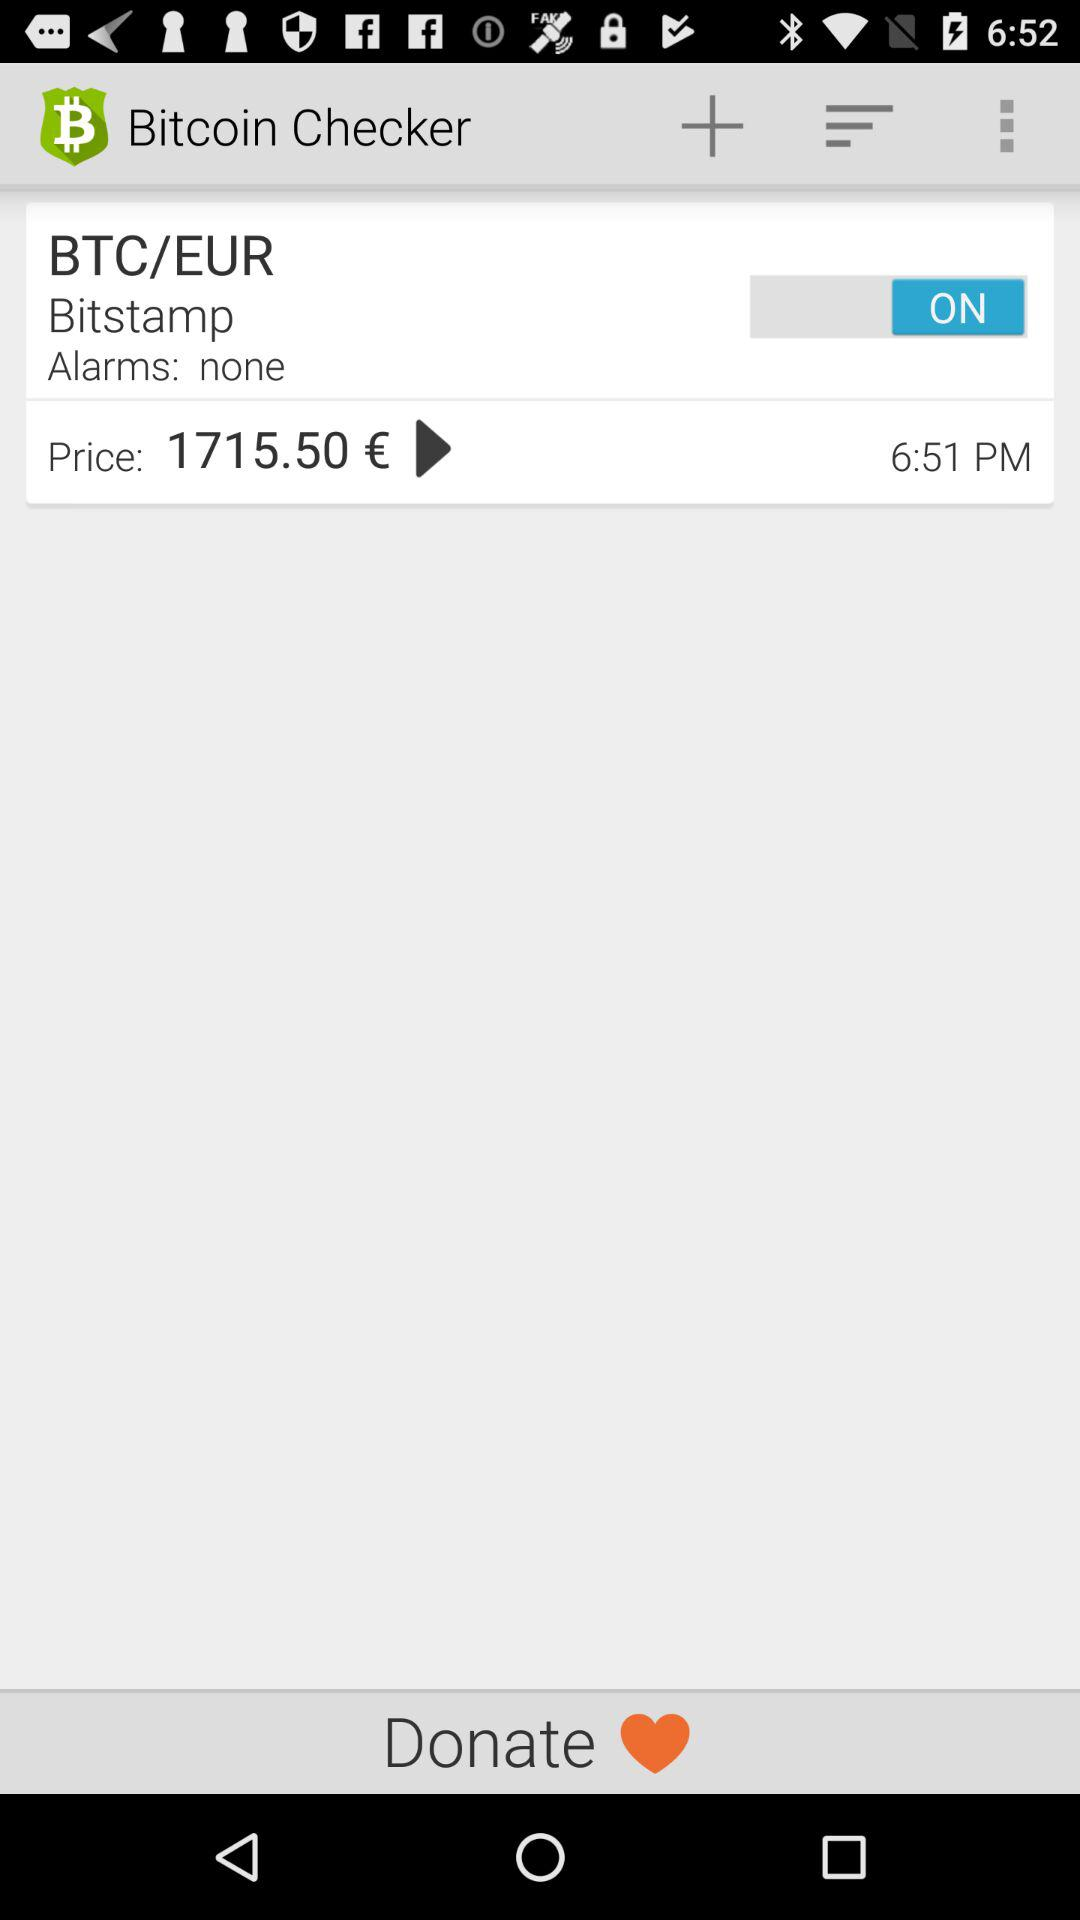Is there any alarm? There is no alarm. 